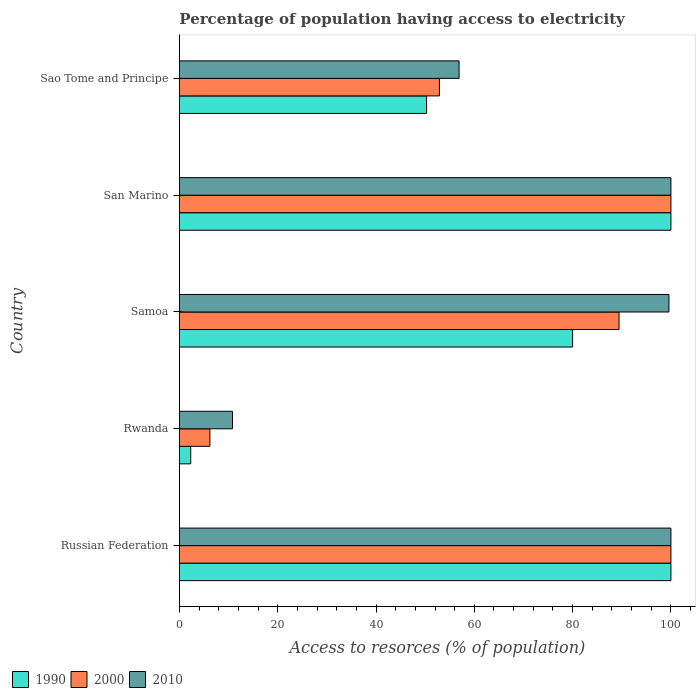How many different coloured bars are there?
Offer a terse response. 3. How many groups of bars are there?
Offer a terse response. 5. What is the label of the 5th group of bars from the top?
Offer a very short reply. Russian Federation. In how many cases, is the number of bars for a given country not equal to the number of legend labels?
Provide a short and direct response. 0. Across all countries, what is the maximum percentage of population having access to electricity in 2000?
Your answer should be very brief. 100. Across all countries, what is the minimum percentage of population having access to electricity in 2000?
Provide a succinct answer. 6.2. In which country was the percentage of population having access to electricity in 1990 maximum?
Give a very brief answer. Russian Federation. In which country was the percentage of population having access to electricity in 2010 minimum?
Offer a terse response. Rwanda. What is the total percentage of population having access to electricity in 2010 in the graph?
Ensure brevity in your answer.  367.3. What is the difference between the percentage of population having access to electricity in 1990 in San Marino and that in Sao Tome and Principe?
Give a very brief answer. 49.71. What is the difference between the percentage of population having access to electricity in 2010 in Russian Federation and the percentage of population having access to electricity in 2000 in San Marino?
Offer a terse response. 0. What is the average percentage of population having access to electricity in 2000 per country?
Offer a terse response. 69.71. What is the difference between the percentage of population having access to electricity in 1990 and percentage of population having access to electricity in 2010 in Rwanda?
Give a very brief answer. -8.5. What is the ratio of the percentage of population having access to electricity in 1990 in Russian Federation to that in San Marino?
Your answer should be very brief. 1. Is the percentage of population having access to electricity in 1990 in Rwanda less than that in Samoa?
Ensure brevity in your answer.  Yes. Is the difference between the percentage of population having access to electricity in 1990 in San Marino and Sao Tome and Principe greater than the difference between the percentage of population having access to electricity in 2010 in San Marino and Sao Tome and Principe?
Ensure brevity in your answer.  Yes. What is the difference between the highest and the lowest percentage of population having access to electricity in 2010?
Provide a short and direct response. 89.2. In how many countries, is the percentage of population having access to electricity in 2010 greater than the average percentage of population having access to electricity in 2010 taken over all countries?
Provide a short and direct response. 3. What does the 2nd bar from the bottom in Rwanda represents?
Keep it short and to the point. 2000. Is it the case that in every country, the sum of the percentage of population having access to electricity in 2000 and percentage of population having access to electricity in 2010 is greater than the percentage of population having access to electricity in 1990?
Offer a very short reply. Yes. How many bars are there?
Offer a terse response. 15. What is the difference between two consecutive major ticks on the X-axis?
Provide a succinct answer. 20. Does the graph contain any zero values?
Offer a very short reply. No. How many legend labels are there?
Give a very brief answer. 3. How are the legend labels stacked?
Offer a terse response. Horizontal. What is the title of the graph?
Offer a very short reply. Percentage of population having access to electricity. What is the label or title of the X-axis?
Offer a very short reply. Access to resorces (% of population). What is the label or title of the Y-axis?
Ensure brevity in your answer.  Country. What is the Access to resorces (% of population) of 2010 in Russian Federation?
Your answer should be compact. 100. What is the Access to resorces (% of population) in 2000 in Rwanda?
Your response must be concise. 6.2. What is the Access to resorces (% of population) of 2010 in Rwanda?
Provide a succinct answer. 10.8. What is the Access to resorces (% of population) of 1990 in Samoa?
Make the answer very short. 80. What is the Access to resorces (% of population) in 2000 in Samoa?
Ensure brevity in your answer.  89.45. What is the Access to resorces (% of population) of 2010 in Samoa?
Give a very brief answer. 99.6. What is the Access to resorces (% of population) in 2000 in San Marino?
Make the answer very short. 100. What is the Access to resorces (% of population) of 2010 in San Marino?
Your answer should be compact. 100. What is the Access to resorces (% of population) of 1990 in Sao Tome and Principe?
Ensure brevity in your answer.  50.29. What is the Access to resorces (% of population) of 2000 in Sao Tome and Principe?
Your answer should be very brief. 52.9. What is the Access to resorces (% of population) of 2010 in Sao Tome and Principe?
Your response must be concise. 56.9. Across all countries, what is the maximum Access to resorces (% of population) in 2000?
Give a very brief answer. 100. Across all countries, what is the minimum Access to resorces (% of population) of 1990?
Provide a short and direct response. 2.3. Across all countries, what is the minimum Access to resorces (% of population) of 2000?
Your answer should be very brief. 6.2. Across all countries, what is the minimum Access to resorces (% of population) in 2010?
Provide a succinct answer. 10.8. What is the total Access to resorces (% of population) of 1990 in the graph?
Keep it short and to the point. 332.59. What is the total Access to resorces (% of population) in 2000 in the graph?
Your answer should be compact. 348.55. What is the total Access to resorces (% of population) of 2010 in the graph?
Ensure brevity in your answer.  367.3. What is the difference between the Access to resorces (% of population) of 1990 in Russian Federation and that in Rwanda?
Ensure brevity in your answer.  97.7. What is the difference between the Access to resorces (% of population) in 2000 in Russian Federation and that in Rwanda?
Give a very brief answer. 93.8. What is the difference between the Access to resorces (% of population) of 2010 in Russian Federation and that in Rwanda?
Your answer should be compact. 89.2. What is the difference between the Access to resorces (% of population) in 1990 in Russian Federation and that in Samoa?
Make the answer very short. 20. What is the difference between the Access to resorces (% of population) of 2000 in Russian Federation and that in Samoa?
Give a very brief answer. 10.55. What is the difference between the Access to resorces (% of population) of 2010 in Russian Federation and that in Samoa?
Offer a terse response. 0.4. What is the difference between the Access to resorces (% of population) in 1990 in Russian Federation and that in San Marino?
Your answer should be very brief. 0. What is the difference between the Access to resorces (% of population) of 2000 in Russian Federation and that in San Marino?
Ensure brevity in your answer.  0. What is the difference between the Access to resorces (% of population) of 2010 in Russian Federation and that in San Marino?
Your answer should be compact. 0. What is the difference between the Access to resorces (% of population) in 1990 in Russian Federation and that in Sao Tome and Principe?
Give a very brief answer. 49.71. What is the difference between the Access to resorces (% of population) in 2000 in Russian Federation and that in Sao Tome and Principe?
Ensure brevity in your answer.  47.1. What is the difference between the Access to resorces (% of population) of 2010 in Russian Federation and that in Sao Tome and Principe?
Make the answer very short. 43.1. What is the difference between the Access to resorces (% of population) in 1990 in Rwanda and that in Samoa?
Offer a very short reply. -77.7. What is the difference between the Access to resorces (% of population) in 2000 in Rwanda and that in Samoa?
Offer a terse response. -83.25. What is the difference between the Access to resorces (% of population) of 2010 in Rwanda and that in Samoa?
Your answer should be very brief. -88.8. What is the difference between the Access to resorces (% of population) in 1990 in Rwanda and that in San Marino?
Give a very brief answer. -97.7. What is the difference between the Access to resorces (% of population) of 2000 in Rwanda and that in San Marino?
Offer a terse response. -93.8. What is the difference between the Access to resorces (% of population) in 2010 in Rwanda and that in San Marino?
Your answer should be compact. -89.2. What is the difference between the Access to resorces (% of population) of 1990 in Rwanda and that in Sao Tome and Principe?
Provide a short and direct response. -47.99. What is the difference between the Access to resorces (% of population) of 2000 in Rwanda and that in Sao Tome and Principe?
Offer a very short reply. -46.7. What is the difference between the Access to resorces (% of population) of 2010 in Rwanda and that in Sao Tome and Principe?
Provide a short and direct response. -46.1. What is the difference between the Access to resorces (% of population) of 2000 in Samoa and that in San Marino?
Keep it short and to the point. -10.55. What is the difference between the Access to resorces (% of population) of 2010 in Samoa and that in San Marino?
Provide a short and direct response. -0.4. What is the difference between the Access to resorces (% of population) of 1990 in Samoa and that in Sao Tome and Principe?
Keep it short and to the point. 29.71. What is the difference between the Access to resorces (% of population) of 2000 in Samoa and that in Sao Tome and Principe?
Your response must be concise. 36.55. What is the difference between the Access to resorces (% of population) of 2010 in Samoa and that in Sao Tome and Principe?
Give a very brief answer. 42.7. What is the difference between the Access to resorces (% of population) in 1990 in San Marino and that in Sao Tome and Principe?
Provide a short and direct response. 49.71. What is the difference between the Access to resorces (% of population) of 2000 in San Marino and that in Sao Tome and Principe?
Your answer should be compact. 47.1. What is the difference between the Access to resorces (% of population) of 2010 in San Marino and that in Sao Tome and Principe?
Provide a succinct answer. 43.1. What is the difference between the Access to resorces (% of population) of 1990 in Russian Federation and the Access to resorces (% of population) of 2000 in Rwanda?
Your response must be concise. 93.8. What is the difference between the Access to resorces (% of population) of 1990 in Russian Federation and the Access to resorces (% of population) of 2010 in Rwanda?
Ensure brevity in your answer.  89.2. What is the difference between the Access to resorces (% of population) in 2000 in Russian Federation and the Access to resorces (% of population) in 2010 in Rwanda?
Keep it short and to the point. 89.2. What is the difference between the Access to resorces (% of population) in 1990 in Russian Federation and the Access to resorces (% of population) in 2000 in Samoa?
Your answer should be very brief. 10.55. What is the difference between the Access to resorces (% of population) of 1990 in Russian Federation and the Access to resorces (% of population) of 2000 in San Marino?
Your response must be concise. 0. What is the difference between the Access to resorces (% of population) of 1990 in Russian Federation and the Access to resorces (% of population) of 2010 in San Marino?
Your answer should be compact. 0. What is the difference between the Access to resorces (% of population) in 1990 in Russian Federation and the Access to resorces (% of population) in 2000 in Sao Tome and Principe?
Your response must be concise. 47.1. What is the difference between the Access to resorces (% of population) in 1990 in Russian Federation and the Access to resorces (% of population) in 2010 in Sao Tome and Principe?
Provide a short and direct response. 43.1. What is the difference between the Access to resorces (% of population) of 2000 in Russian Federation and the Access to resorces (% of population) of 2010 in Sao Tome and Principe?
Provide a short and direct response. 43.1. What is the difference between the Access to resorces (% of population) in 1990 in Rwanda and the Access to resorces (% of population) in 2000 in Samoa?
Offer a very short reply. -87.15. What is the difference between the Access to resorces (% of population) of 1990 in Rwanda and the Access to resorces (% of population) of 2010 in Samoa?
Offer a very short reply. -97.3. What is the difference between the Access to resorces (% of population) of 2000 in Rwanda and the Access to resorces (% of population) of 2010 in Samoa?
Offer a very short reply. -93.4. What is the difference between the Access to resorces (% of population) in 1990 in Rwanda and the Access to resorces (% of population) in 2000 in San Marino?
Give a very brief answer. -97.7. What is the difference between the Access to resorces (% of population) in 1990 in Rwanda and the Access to resorces (% of population) in 2010 in San Marino?
Provide a succinct answer. -97.7. What is the difference between the Access to resorces (% of population) in 2000 in Rwanda and the Access to resorces (% of population) in 2010 in San Marino?
Give a very brief answer. -93.8. What is the difference between the Access to resorces (% of population) of 1990 in Rwanda and the Access to resorces (% of population) of 2000 in Sao Tome and Principe?
Offer a very short reply. -50.6. What is the difference between the Access to resorces (% of population) in 1990 in Rwanda and the Access to resorces (% of population) in 2010 in Sao Tome and Principe?
Offer a very short reply. -54.6. What is the difference between the Access to resorces (% of population) in 2000 in Rwanda and the Access to resorces (% of population) in 2010 in Sao Tome and Principe?
Give a very brief answer. -50.7. What is the difference between the Access to resorces (% of population) in 2000 in Samoa and the Access to resorces (% of population) in 2010 in San Marino?
Your response must be concise. -10.55. What is the difference between the Access to resorces (% of population) of 1990 in Samoa and the Access to resorces (% of population) of 2000 in Sao Tome and Principe?
Give a very brief answer. 27.1. What is the difference between the Access to resorces (% of population) in 1990 in Samoa and the Access to resorces (% of population) in 2010 in Sao Tome and Principe?
Keep it short and to the point. 23.1. What is the difference between the Access to resorces (% of population) in 2000 in Samoa and the Access to resorces (% of population) in 2010 in Sao Tome and Principe?
Keep it short and to the point. 32.55. What is the difference between the Access to resorces (% of population) of 1990 in San Marino and the Access to resorces (% of population) of 2000 in Sao Tome and Principe?
Offer a very short reply. 47.1. What is the difference between the Access to resorces (% of population) in 1990 in San Marino and the Access to resorces (% of population) in 2010 in Sao Tome and Principe?
Ensure brevity in your answer.  43.1. What is the difference between the Access to resorces (% of population) in 2000 in San Marino and the Access to resorces (% of population) in 2010 in Sao Tome and Principe?
Keep it short and to the point. 43.1. What is the average Access to resorces (% of population) of 1990 per country?
Ensure brevity in your answer.  66.52. What is the average Access to resorces (% of population) of 2000 per country?
Provide a short and direct response. 69.71. What is the average Access to resorces (% of population) of 2010 per country?
Give a very brief answer. 73.46. What is the difference between the Access to resorces (% of population) in 1990 and Access to resorces (% of population) in 2010 in Russian Federation?
Offer a terse response. 0. What is the difference between the Access to resorces (% of population) of 1990 and Access to resorces (% of population) of 2000 in Rwanda?
Provide a succinct answer. -3.9. What is the difference between the Access to resorces (% of population) in 2000 and Access to resorces (% of population) in 2010 in Rwanda?
Offer a terse response. -4.6. What is the difference between the Access to resorces (% of population) of 1990 and Access to resorces (% of population) of 2000 in Samoa?
Your answer should be very brief. -9.45. What is the difference between the Access to resorces (% of population) of 1990 and Access to resorces (% of population) of 2010 in Samoa?
Keep it short and to the point. -19.6. What is the difference between the Access to resorces (% of population) of 2000 and Access to resorces (% of population) of 2010 in Samoa?
Your answer should be very brief. -10.15. What is the difference between the Access to resorces (% of population) in 1990 and Access to resorces (% of population) in 2000 in San Marino?
Your answer should be very brief. 0. What is the difference between the Access to resorces (% of population) in 1990 and Access to resorces (% of population) in 2010 in San Marino?
Offer a terse response. 0. What is the difference between the Access to resorces (% of population) of 2000 and Access to resorces (% of population) of 2010 in San Marino?
Your response must be concise. 0. What is the difference between the Access to resorces (% of population) in 1990 and Access to resorces (% of population) in 2000 in Sao Tome and Principe?
Provide a succinct answer. -2.61. What is the difference between the Access to resorces (% of population) in 1990 and Access to resorces (% of population) in 2010 in Sao Tome and Principe?
Provide a short and direct response. -6.61. What is the difference between the Access to resorces (% of population) in 2000 and Access to resorces (% of population) in 2010 in Sao Tome and Principe?
Your response must be concise. -4. What is the ratio of the Access to resorces (% of population) of 1990 in Russian Federation to that in Rwanda?
Make the answer very short. 43.48. What is the ratio of the Access to resorces (% of population) of 2000 in Russian Federation to that in Rwanda?
Give a very brief answer. 16.13. What is the ratio of the Access to resorces (% of population) of 2010 in Russian Federation to that in Rwanda?
Your answer should be compact. 9.26. What is the ratio of the Access to resorces (% of population) in 1990 in Russian Federation to that in Samoa?
Make the answer very short. 1.25. What is the ratio of the Access to resorces (% of population) in 2000 in Russian Federation to that in Samoa?
Keep it short and to the point. 1.12. What is the ratio of the Access to resorces (% of population) in 1990 in Russian Federation to that in San Marino?
Give a very brief answer. 1. What is the ratio of the Access to resorces (% of population) in 2010 in Russian Federation to that in San Marino?
Make the answer very short. 1. What is the ratio of the Access to resorces (% of population) in 1990 in Russian Federation to that in Sao Tome and Principe?
Ensure brevity in your answer.  1.99. What is the ratio of the Access to resorces (% of population) in 2000 in Russian Federation to that in Sao Tome and Principe?
Provide a short and direct response. 1.89. What is the ratio of the Access to resorces (% of population) of 2010 in Russian Federation to that in Sao Tome and Principe?
Give a very brief answer. 1.76. What is the ratio of the Access to resorces (% of population) of 1990 in Rwanda to that in Samoa?
Provide a succinct answer. 0.03. What is the ratio of the Access to resorces (% of population) in 2000 in Rwanda to that in Samoa?
Ensure brevity in your answer.  0.07. What is the ratio of the Access to resorces (% of population) of 2010 in Rwanda to that in Samoa?
Make the answer very short. 0.11. What is the ratio of the Access to resorces (% of population) of 1990 in Rwanda to that in San Marino?
Your answer should be very brief. 0.02. What is the ratio of the Access to resorces (% of population) of 2000 in Rwanda to that in San Marino?
Provide a succinct answer. 0.06. What is the ratio of the Access to resorces (% of population) of 2010 in Rwanda to that in San Marino?
Keep it short and to the point. 0.11. What is the ratio of the Access to resorces (% of population) of 1990 in Rwanda to that in Sao Tome and Principe?
Ensure brevity in your answer.  0.05. What is the ratio of the Access to resorces (% of population) in 2000 in Rwanda to that in Sao Tome and Principe?
Make the answer very short. 0.12. What is the ratio of the Access to resorces (% of population) of 2010 in Rwanda to that in Sao Tome and Principe?
Ensure brevity in your answer.  0.19. What is the ratio of the Access to resorces (% of population) in 1990 in Samoa to that in San Marino?
Keep it short and to the point. 0.8. What is the ratio of the Access to resorces (% of population) in 2000 in Samoa to that in San Marino?
Provide a succinct answer. 0.89. What is the ratio of the Access to resorces (% of population) of 1990 in Samoa to that in Sao Tome and Principe?
Give a very brief answer. 1.59. What is the ratio of the Access to resorces (% of population) of 2000 in Samoa to that in Sao Tome and Principe?
Your answer should be compact. 1.69. What is the ratio of the Access to resorces (% of population) of 2010 in Samoa to that in Sao Tome and Principe?
Offer a very short reply. 1.75. What is the ratio of the Access to resorces (% of population) in 1990 in San Marino to that in Sao Tome and Principe?
Your response must be concise. 1.99. What is the ratio of the Access to resorces (% of population) in 2000 in San Marino to that in Sao Tome and Principe?
Make the answer very short. 1.89. What is the ratio of the Access to resorces (% of population) of 2010 in San Marino to that in Sao Tome and Principe?
Make the answer very short. 1.76. What is the difference between the highest and the second highest Access to resorces (% of population) in 2010?
Ensure brevity in your answer.  0. What is the difference between the highest and the lowest Access to resorces (% of population) of 1990?
Give a very brief answer. 97.7. What is the difference between the highest and the lowest Access to resorces (% of population) in 2000?
Make the answer very short. 93.8. What is the difference between the highest and the lowest Access to resorces (% of population) in 2010?
Provide a succinct answer. 89.2. 